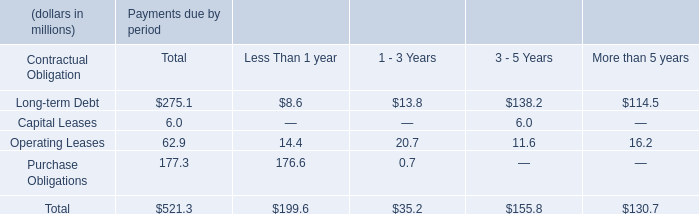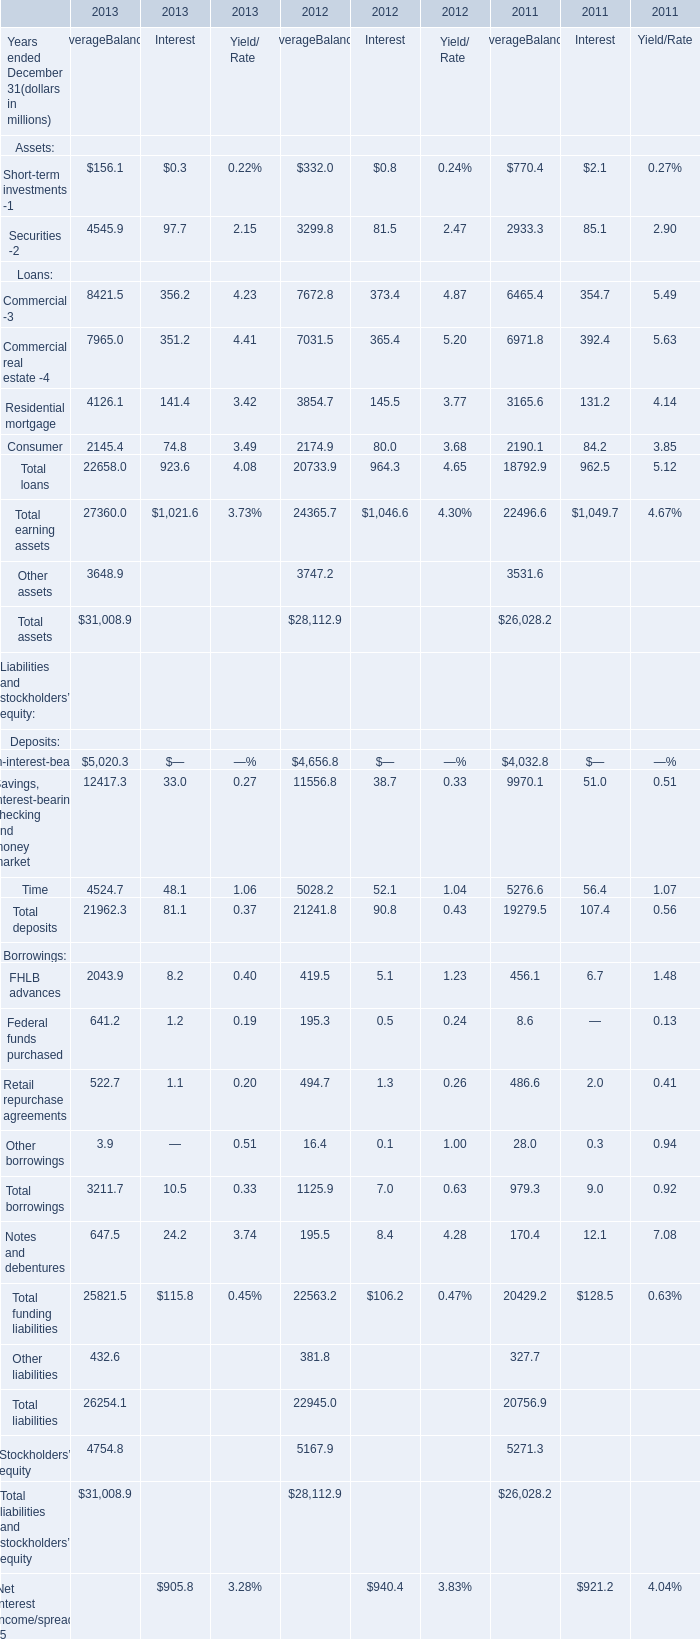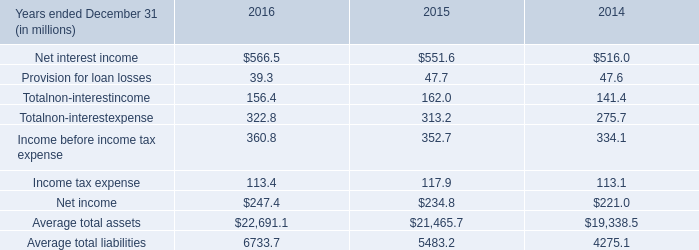What is the growth rate of Average Balance for Other assets between 2011 ended December 31 and 2012 ended December 31? 
Computations: ((3747.2 - 3531.6) / 3531.6)
Answer: 0.06105. 